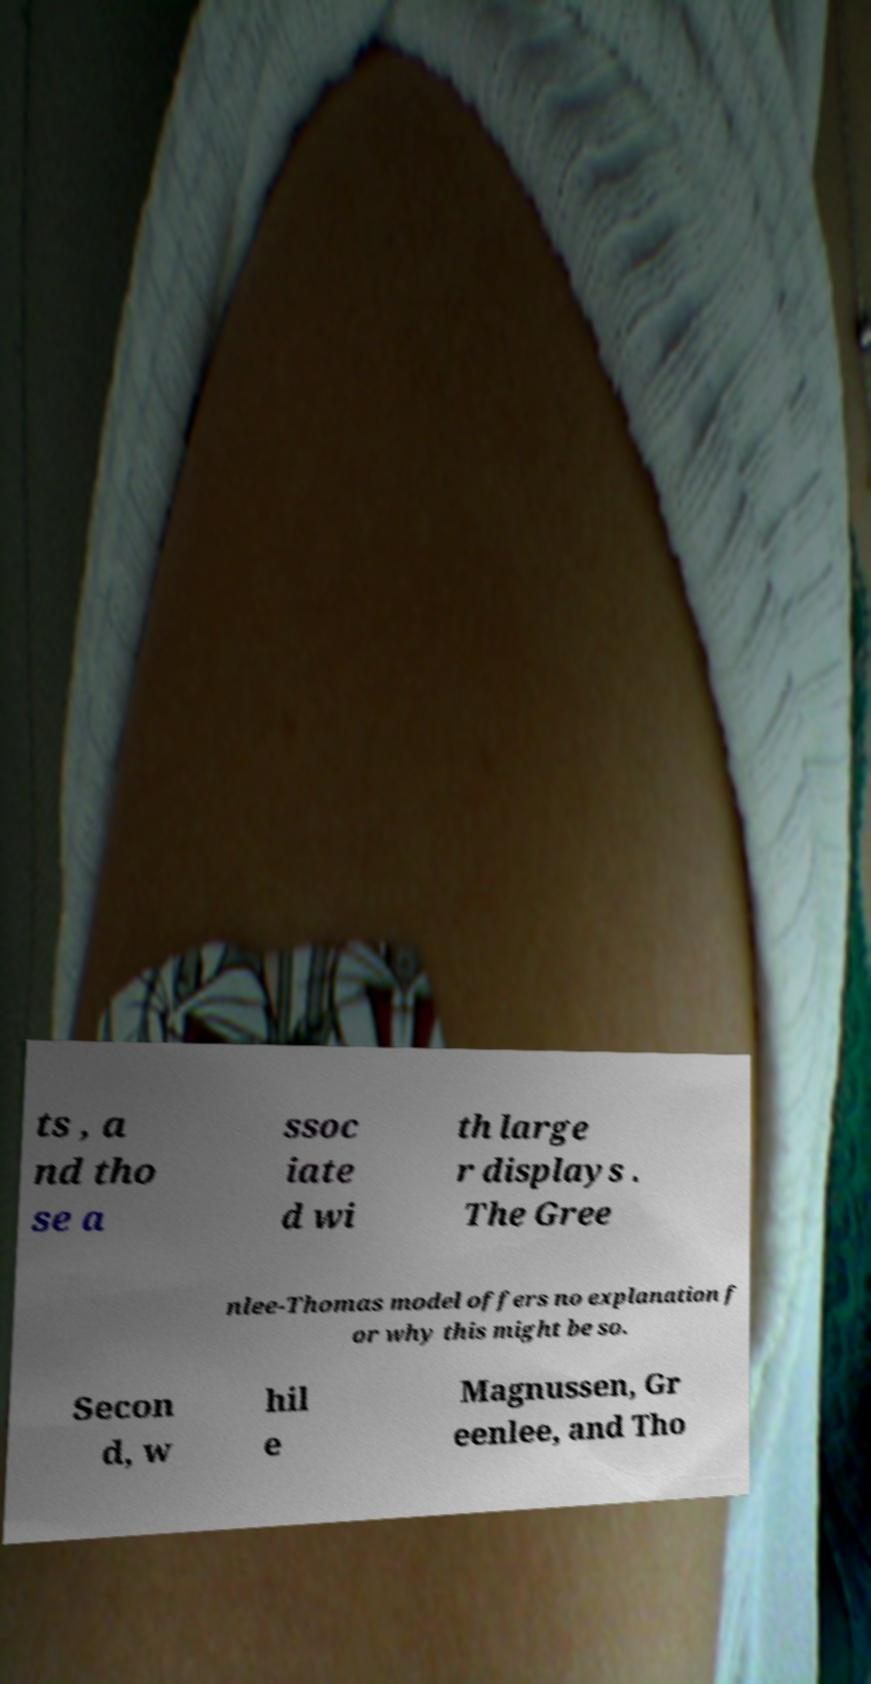Please identify and transcribe the text found in this image. ts , a nd tho se a ssoc iate d wi th large r displays . The Gree nlee-Thomas model offers no explanation f or why this might be so. Secon d, w hil e Magnussen, Gr eenlee, and Tho 